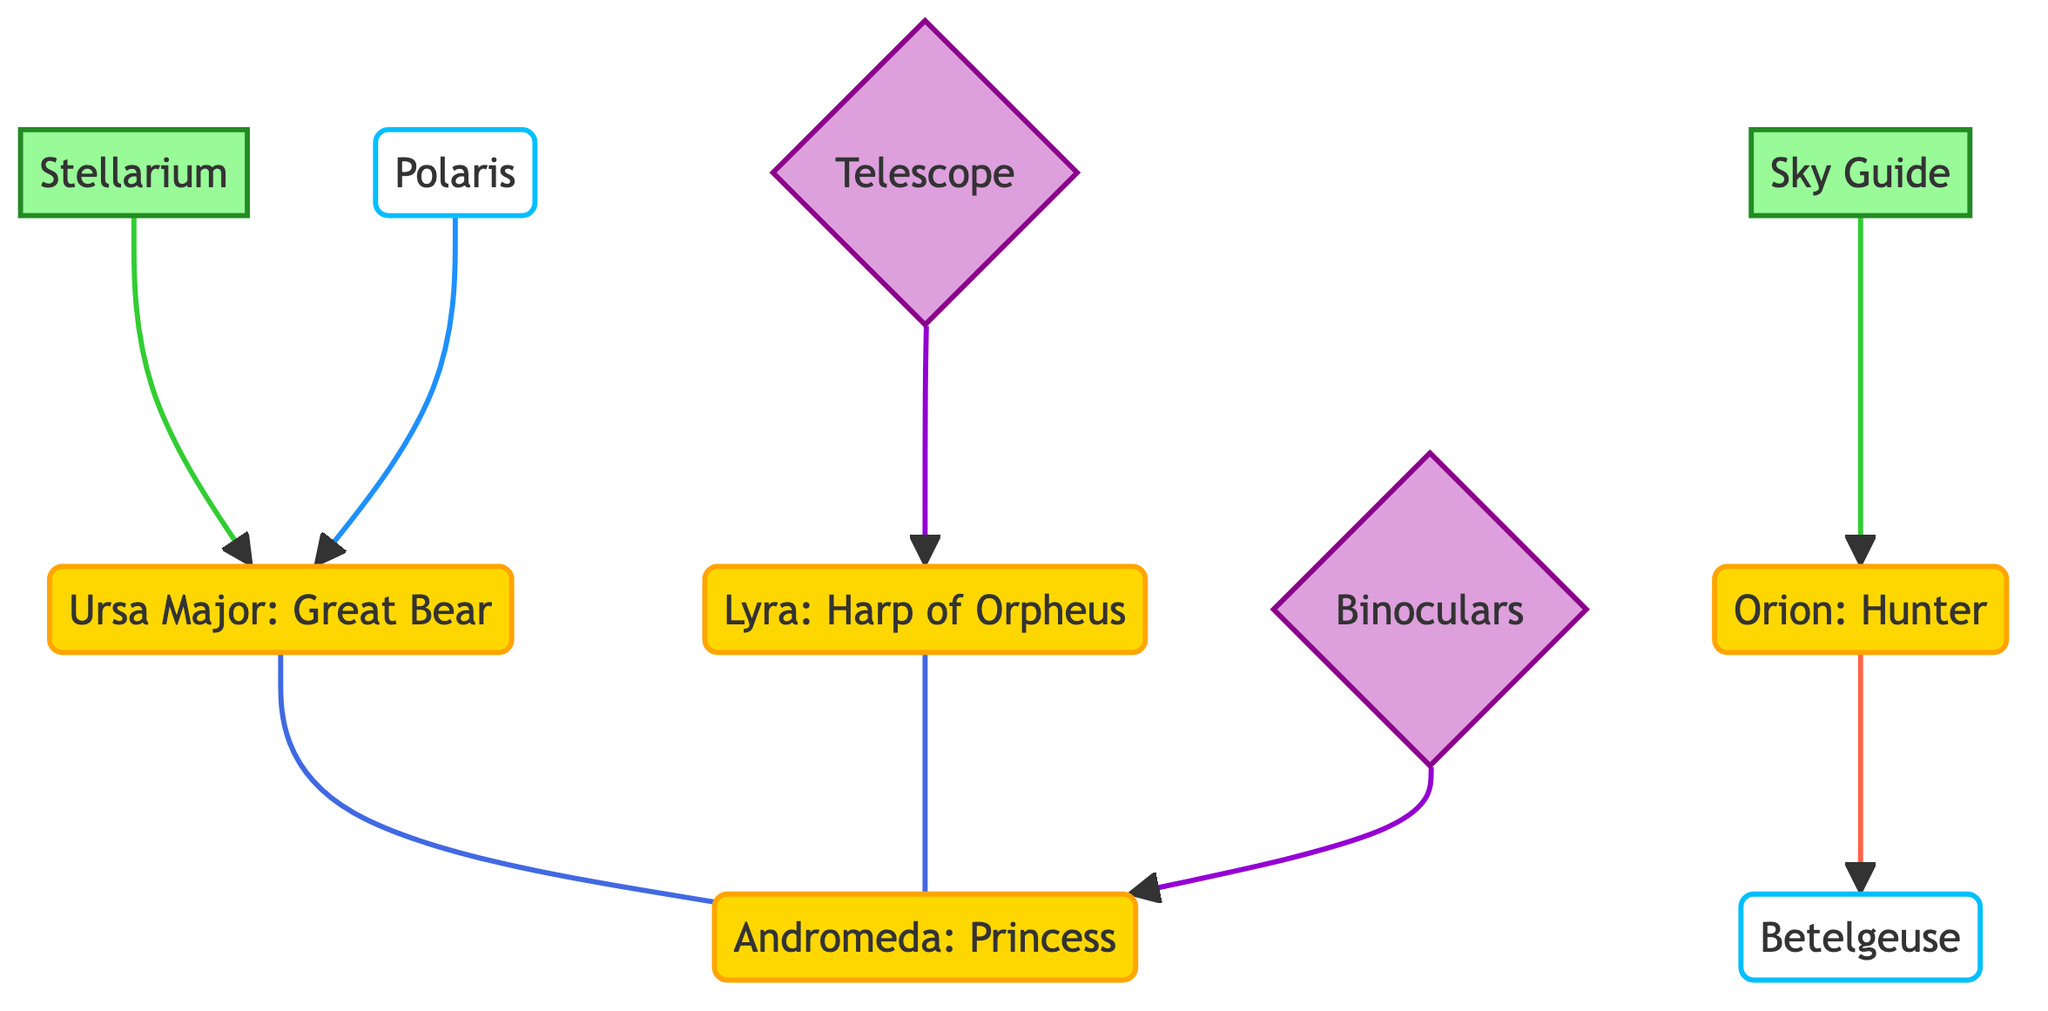What are two major constellations shown in the diagram? The diagram prominently features Orion and Ursa Major. These names can be directly identified from the diagram under the constellation nodes.
Answer: Orion, Ursa Major How many stars are highlighted in the diagram? There are two stars indicated in the diagram: Betelgeuse and Polaris. This can be verified by counting the star nodes connected to the constellation nodes.
Answer: 2 Which app is associated with the constellation Orion? The app Sky Guide is connected to the Orion constellation in the diagram. This relationship is shown by a directional arrow from the app node to the Orion node.
Answer: Sky Guide What is the relationship between Ursa Major and Andromeda? Ursa Major and Andromeda are linked by a dashed line, indicating a non-directional connection between the two constellations in the diagram.
Answer: Undirected connection Which two stargazing tools are represented? The stargazing tools in the diagram are a telescope and binoculars. Each is visually represented as a distinct node and can be identified from the device section of the diagram.
Answer: Telescope, Binoculars Which constellation is connected to Polaris? The constellation Ursa Major is connected to Polaris in the diagram. This is indicated by the direct connection line that shows Polaris leading to Ursa Major.
Answer: Ursa Major How many applications are featured in the diagram? There are two applications highlighted in the diagram: Sky Guide and Stellarium. This can be confirmed by counting the app nodes.
Answer: 2 What star is associated with the constellation Lyra? The diagram does not indicate a specific star connected to Lyra; therefore, it can be inferred that Lyra is not directly linked to any star within this representation.
Answer: None indicated 